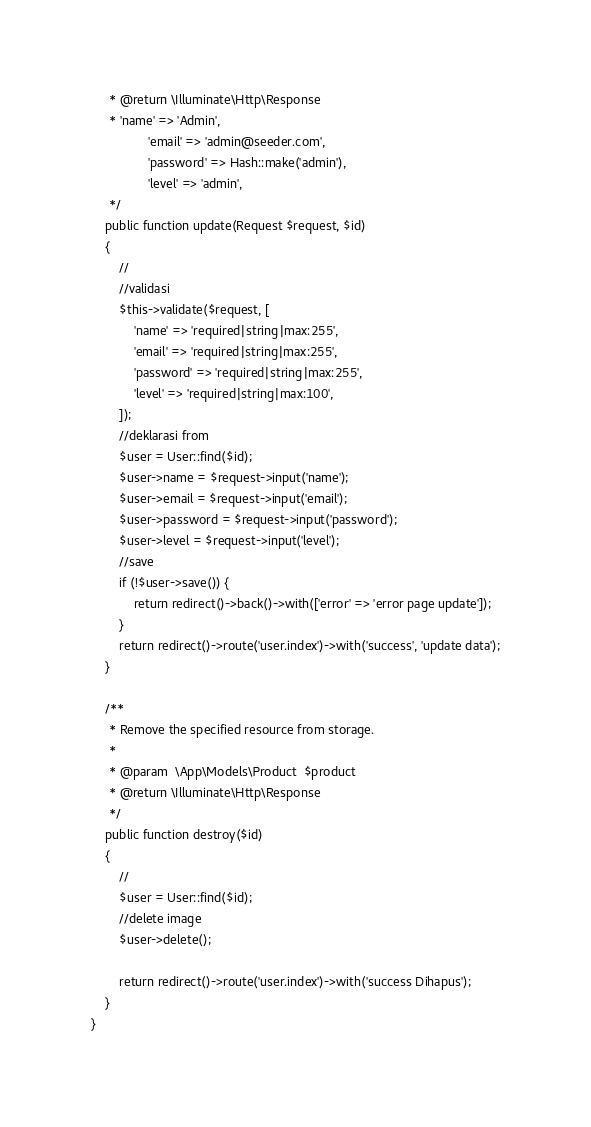Convert code to text. <code><loc_0><loc_0><loc_500><loc_500><_PHP_>     * @return \Illuminate\Http\Response
     * 'name' => 'Admin',
                'email' => 'admin@seeder.com',
                'password' => Hash::make('admin'),
                'level' => 'admin',
     */
    public function update(Request $request, $id)
    {
        //
        //validasi
        $this->validate($request, [
            'name' => 'required|string|max:255',
            'email' => 'required|string|max:255',
            'password' => 'required|string|max:255',
            'level' => 'required|string|max:100',
        ]);
        //deklarasi from
        $user = User::find($id);
        $user->name = $request->input('name');
        $user->email = $request->input('email');
        $user->password = $request->input('password');
        $user->level = $request->input('level');
        //save
        if (!$user->save()) {
            return redirect()->back()->with(['error' => 'error page update']);
        }
        return redirect()->route('user.index')->with('success', 'update data');
    }

    /**
     * Remove the specified resource from storage.
     *
     * @param  \App\Models\Product  $product
     * @return \Illuminate\Http\Response
     */
    public function destroy($id)
    {
        //
        $user = User::find($id);
        //delete image
        $user->delete();

        return redirect()->route('user.index')->with('success Dihapus');
    }
}
</code> 